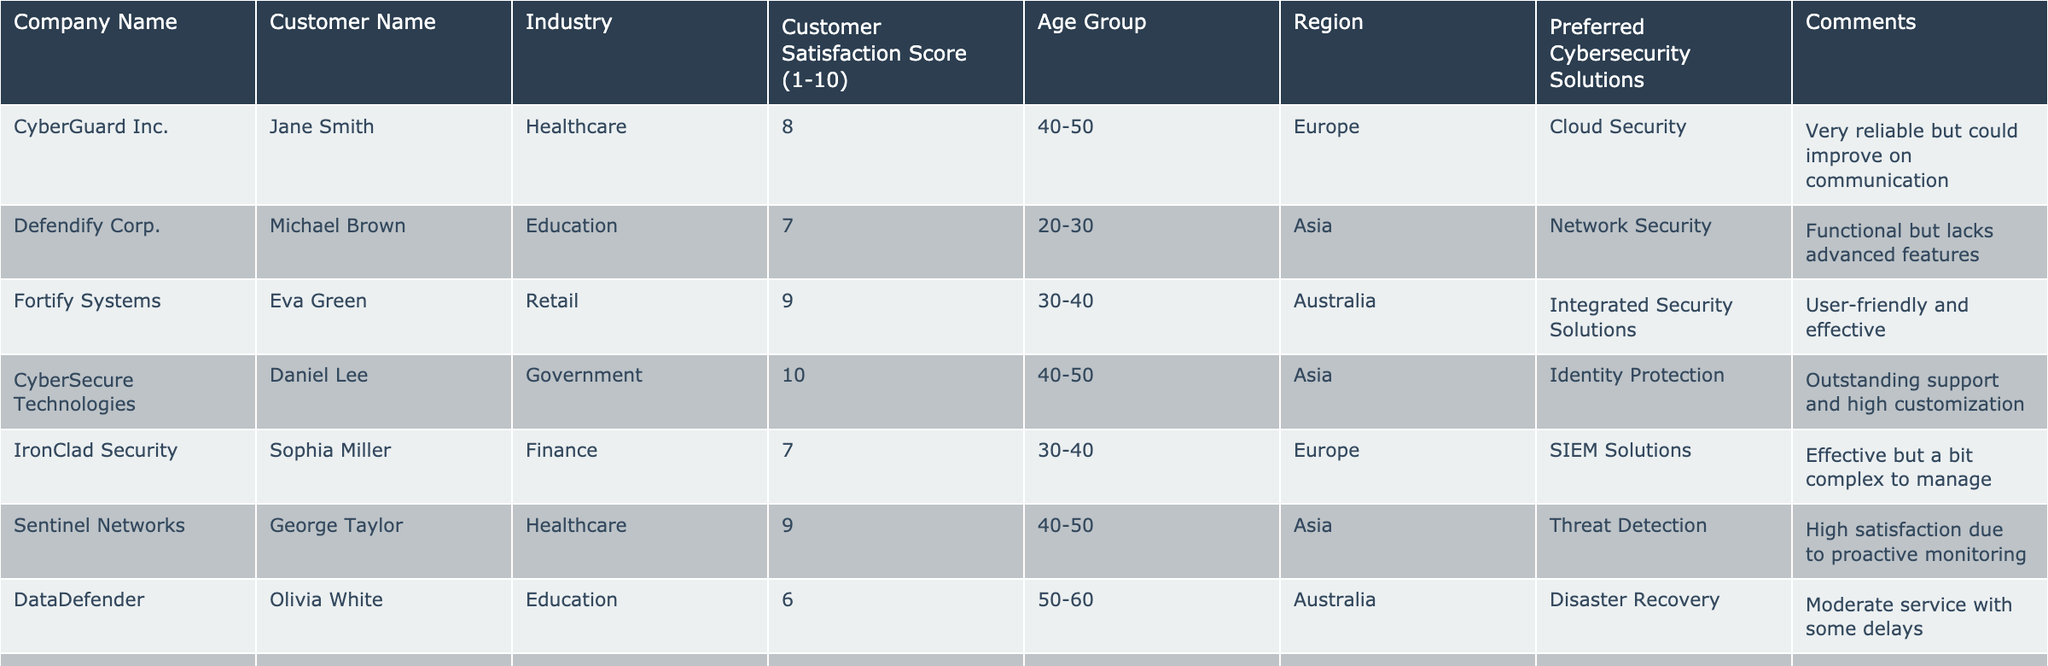What is the customer satisfaction score of CyberSecure Technologies? The score is directly listed in the table under the "Customer Satisfaction Score" column for CyberSecure Technologies. It shows a score of 10.
Answer: 10 How many companies have a customer satisfaction score of 8 or higher? By counting the scores listed in the table, there are 5 companies with scores of 8 or higher: CyberGuard Inc. (8), Fortify Systems (9), CyberSecure Technologies (10), Sentinel Networks (9), and Armorify (9).
Answer: 5 Is there any company in the Education sector that has a customer satisfaction score below 7? There is one company in the Education sector, DataDefender, with a score of 6, which is below 7.
Answer: Yes What is the average customer satisfaction score for companies in the Healthcare sector? The scores for the Healthcare sector are 8 (CyberGuard Inc.) and 9 (Sentinel Networks). The average is (8 + 9) / 2 = 8.5.
Answer: 8.5 Which region has the highest scoring company? CyberSecure Technologies from the Asia region has the highest score of 10, which is the highest overall in the table.
Answer: Asia What is the difference between the highest and lowest customer satisfaction scores in the table? The highest score is 10 (CyberSecure Technologies) and the lowest score is 6 (DataDefender). The difference is 10 - 6 = 4.
Answer: 4 How many companies scored a 7 in the Retail industry? TrustWave Security and Fortify Systems both scored 7 in the Retail industry, so we count 2 companies.
Answer: 2 Which age group has the most companies listed in the table? Upon examining the "Age Group" column, we find that the 40-50 age group appears 5 times, which is the most frequent.
Answer: 40-50 What are the preferred cybersecurity solutions of companies with a customer satisfaction score of 9 or 10? The preferred solutions for these companies are: Integrated Security Solutions (Fortify Systems), Identity Protection (CyberSecure Technologies), Threat Detection (Sentinel Networks), and Cybersecurity Consulting (Armorify).
Answer: 4 Solutions listed Are there any comments mentioning high levels of service or support? Yes, the comments from CyberSecure Technologies mention "Outstanding support" and Armorify mentions "Personalized plans worked wonders," indicating high levels of service or support.
Answer: Yes 